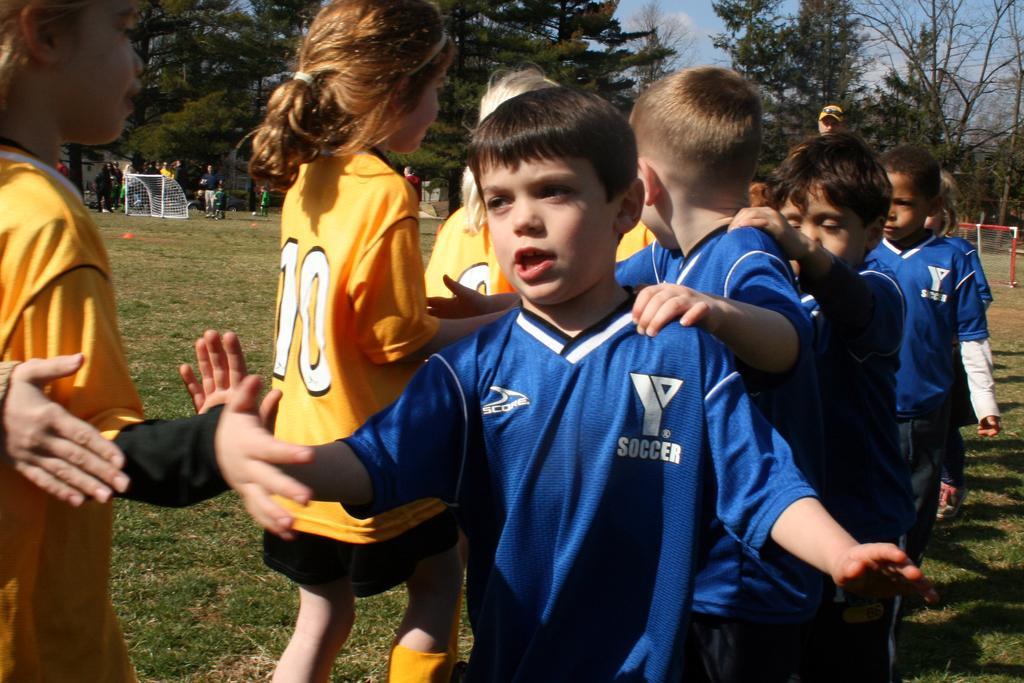Please provide a concise description of this image. In this picture there are some small boys wearing blue color t-shirt is moving in the ground. Beside there are some girls wearing yellow t-shirt, both are slapping the hand. Behind there is a white color football net and some trees. 